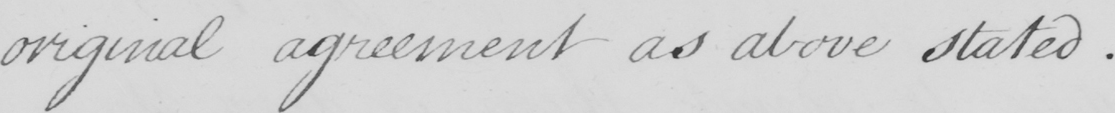Transcribe the text shown in this historical manuscript line. original agreement as above stated . 